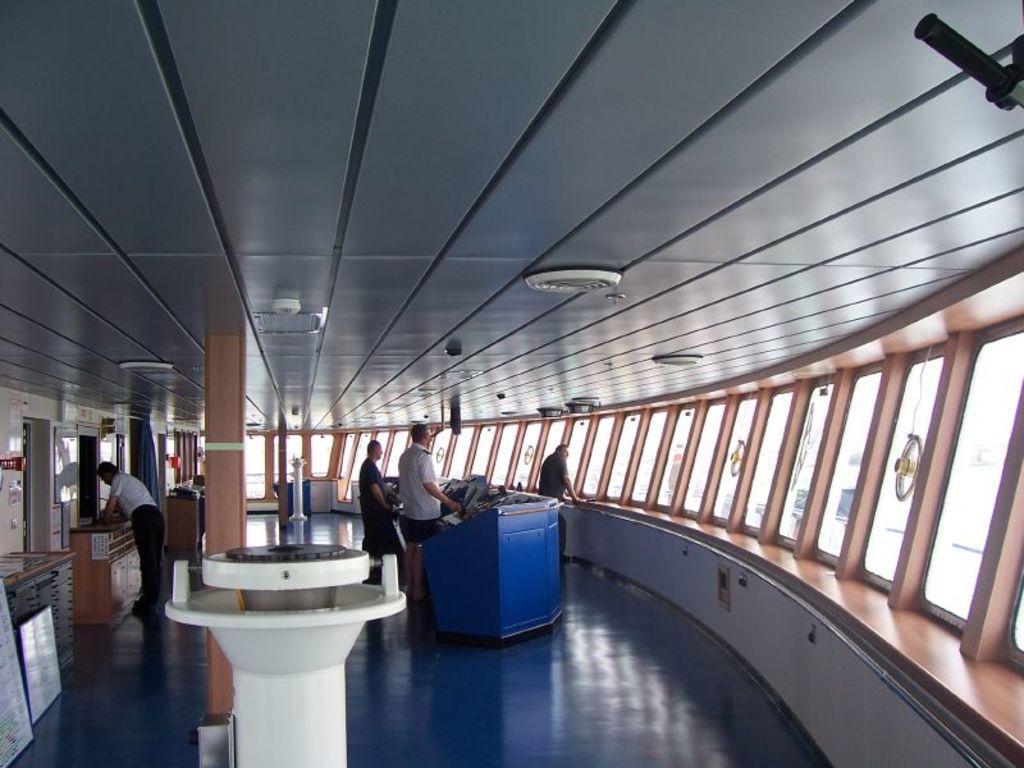Please provide a concise description of this image. In this image we can see an inside view of a room, group of persons are standing on the floor. To the left side of the image we can see some boards placed on the ground. In the foreground we can see some tables. In the background, we can see windows, fans, curtains, pillars and dome lights. 